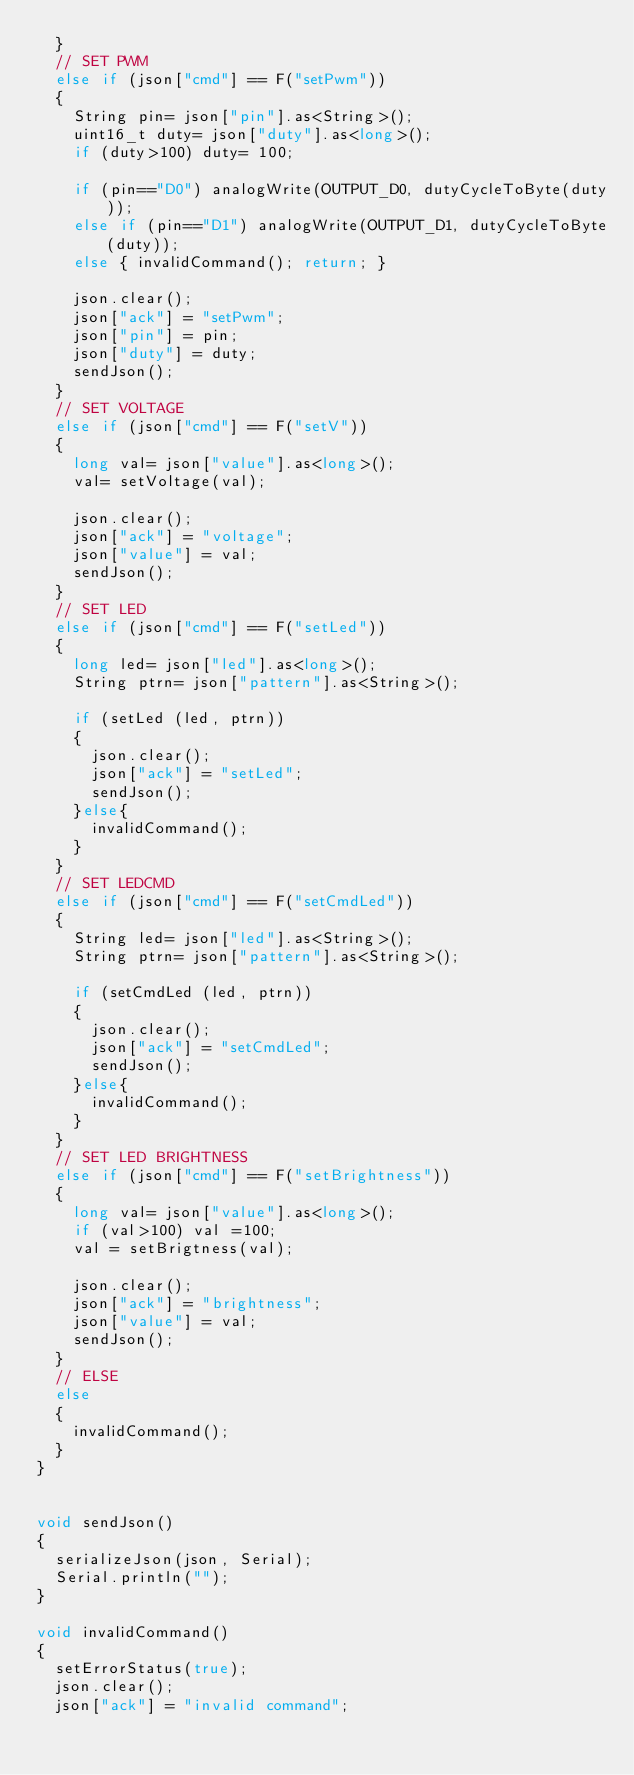<code> <loc_0><loc_0><loc_500><loc_500><_C++_>  }
  // SET PWM
  else if (json["cmd"] == F("setPwm"))
  {
    String pin= json["pin"].as<String>();
    uint16_t duty= json["duty"].as<long>();
    if (duty>100) duty= 100;

    if (pin=="D0") analogWrite(OUTPUT_D0, dutyCycleToByte(duty));
    else if (pin=="D1") analogWrite(OUTPUT_D1, dutyCycleToByte(duty));
    else { invalidCommand(); return; }
    
    json.clear();
    json["ack"] = "setPwm";
    json["pin"] = pin;
    json["duty"] = duty;
    sendJson();
  }
  // SET VOLTAGE
  else if (json["cmd"] == F("setV"))
  {
    long val= json["value"].as<long>();
    val= setVoltage(val);
    
    json.clear();
    json["ack"] = "voltage";
    json["value"] = val;
    sendJson();
  }
  // SET LED
  else if (json["cmd"] == F("setLed"))
  {
    long led= json["led"].as<long>();
    String ptrn= json["pattern"].as<String>();

    if (setLed (led, ptrn))
    {
      json.clear();
      json["ack"] = "setLed";
      sendJson();
    }else{
      invalidCommand();
    }
  }
  // SET LEDCMD
  else if (json["cmd"] == F("setCmdLed"))
  {
    String led= json["led"].as<String>();
    String ptrn= json["pattern"].as<String>();
  
    if (setCmdLed (led, ptrn))
    {
      json.clear();
      json["ack"] = "setCmdLed";
      sendJson();
    }else{
      invalidCommand();
    }
  }
  // SET LED BRIGHTNESS
  else if (json["cmd"] == F("setBrightness"))
  {
    long val= json["value"].as<long>();
    if (val>100) val =100;
    val = setBrigtness(val);
    
    json.clear();
    json["ack"] = "brightness";
    json["value"] = val;
    sendJson();
  }
  // ELSE
  else
  {
    invalidCommand();
  }
}


void sendJson()
{
  serializeJson(json, Serial);
  Serial.println("");
}

void invalidCommand()
{
  setErrorStatus(true); 
  json.clear();
  json["ack"] = "invalid command";</code> 